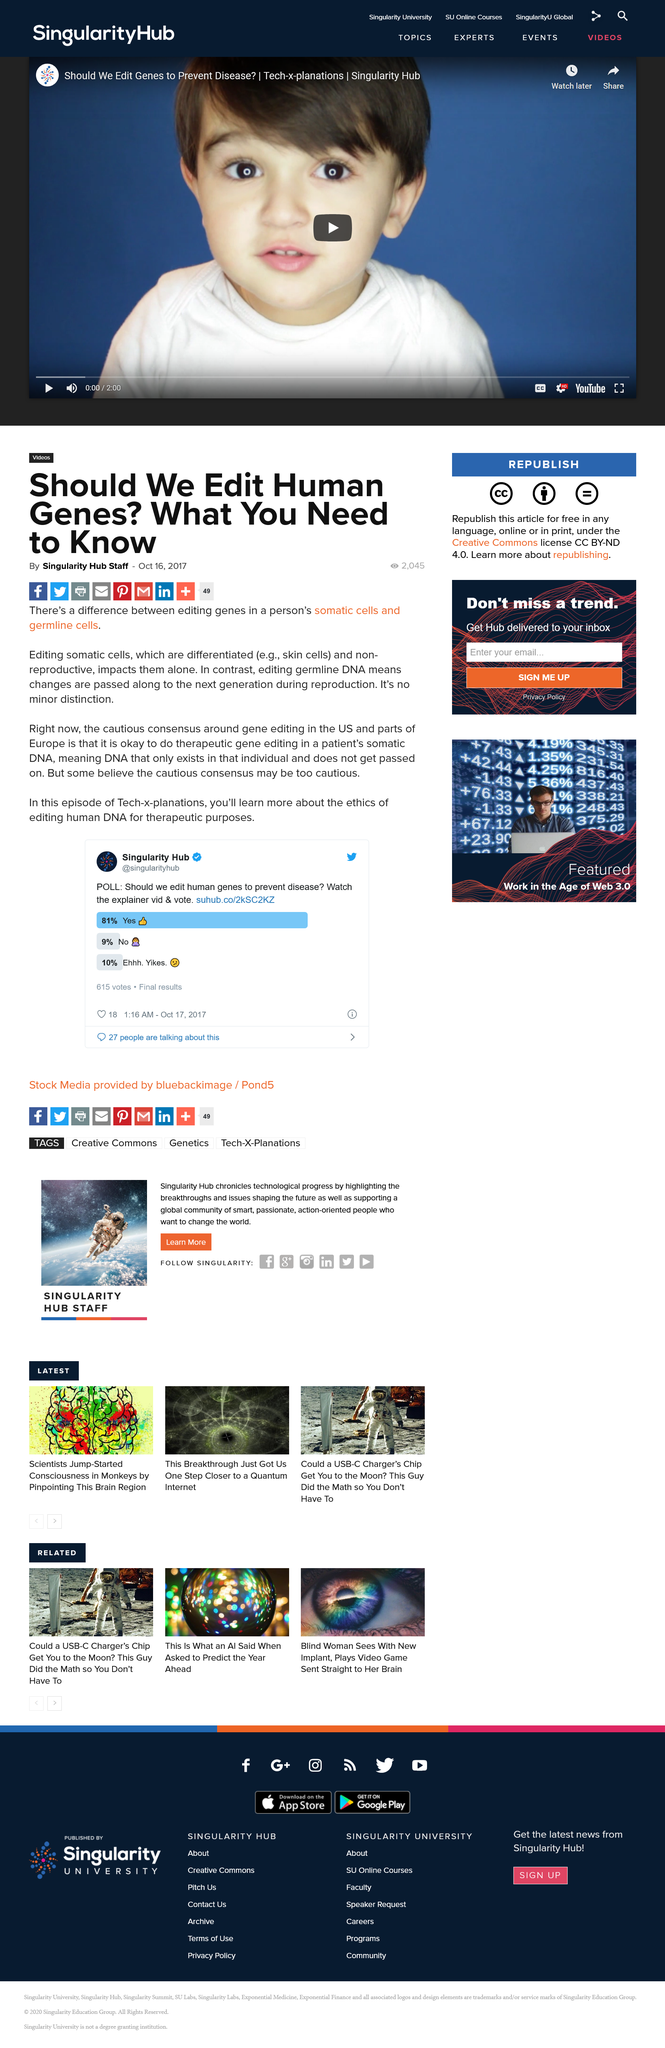List a handful of essential elements in this visual. Some believe that the cautious consensus may be too cautious. The article on whether or not human genes should be edited was published on October 16, 2017. The article on whether or not human genes should be edited was written by the Singularity Hub Staff. 